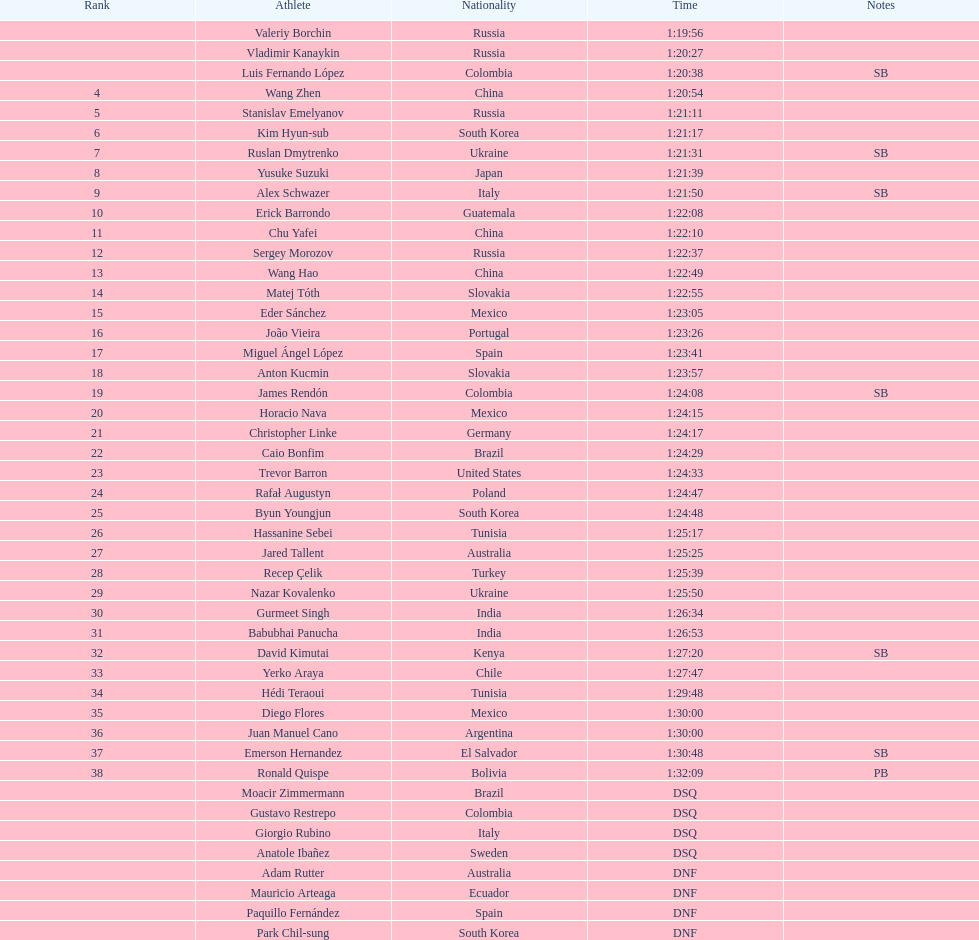How many participants hailed from russia? 4. 